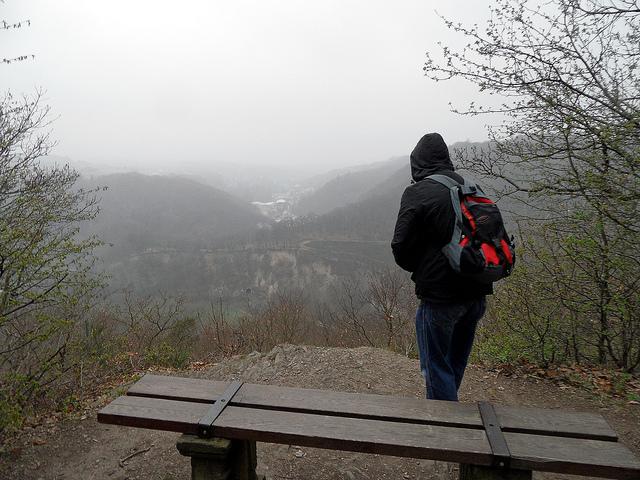What is on the person's back?
Keep it brief. Backpack. Is the person hiking?
Write a very short answer. Yes. Is it cold in this picture?
Short answer required. Yes. How many power poles are there?
Short answer required. 0. 